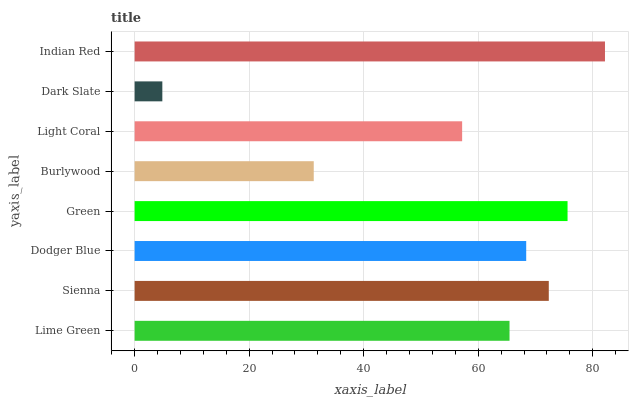Is Dark Slate the minimum?
Answer yes or no. Yes. Is Indian Red the maximum?
Answer yes or no. Yes. Is Sienna the minimum?
Answer yes or no. No. Is Sienna the maximum?
Answer yes or no. No. Is Sienna greater than Lime Green?
Answer yes or no. Yes. Is Lime Green less than Sienna?
Answer yes or no. Yes. Is Lime Green greater than Sienna?
Answer yes or no. No. Is Sienna less than Lime Green?
Answer yes or no. No. Is Dodger Blue the high median?
Answer yes or no. Yes. Is Lime Green the low median?
Answer yes or no. Yes. Is Light Coral the high median?
Answer yes or no. No. Is Indian Red the low median?
Answer yes or no. No. 